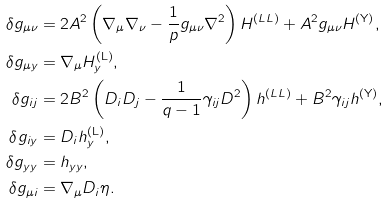<formula> <loc_0><loc_0><loc_500><loc_500>\delta g _ { \mu \nu } & = 2 A ^ { 2 } \left ( \nabla _ { \mu } \nabla _ { \nu } - \frac { 1 } { p } g _ { \mu \nu } \nabla ^ { 2 } \right ) H ^ { ( L L ) } + A ^ { 2 } g _ { \mu \nu } H ^ { ( \mathrm Y ) } , \\ \delta g _ { \mu y } & = \nabla _ { \mu } H _ { y } ^ { ( \mathrm L ) } , \\ \delta g _ { i j } & = 2 B ^ { 2 } \left ( D _ { i } D _ { j } - \frac { 1 } { q - 1 } \gamma _ { i j } D ^ { 2 } \right ) h ^ { ( L L ) } + B ^ { 2 } \gamma _ { i j } h ^ { ( \mathrm Y ) } , \\ \delta g _ { i y } & = D _ { i } h _ { y } ^ { ( \mathrm L ) } , \\ \delta g _ { y y } & = h _ { y y } , \\ \delta g _ { \mu i } & = \nabla _ { \mu } D _ { i } \eta .</formula> 